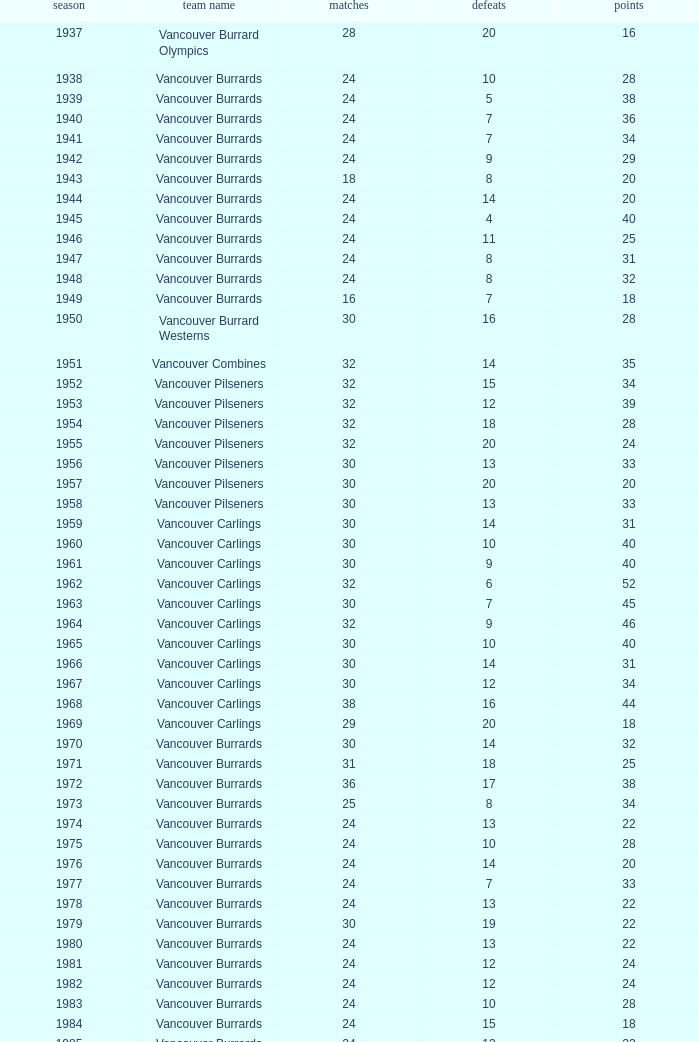What's the total number of games with more than 20 points for the 1976 season? 0.0. Can you parse all the data within this table? {'header': ['season', 'team name', 'matches', 'defeats', 'points'], 'rows': [['1937', 'Vancouver Burrard Olympics', '28', '20', '16'], ['1938', 'Vancouver Burrards', '24', '10', '28'], ['1939', 'Vancouver Burrards', '24', '5', '38'], ['1940', 'Vancouver Burrards', '24', '7', '36'], ['1941', 'Vancouver Burrards', '24', '7', '34'], ['1942', 'Vancouver Burrards', '24', '9', '29'], ['1943', 'Vancouver Burrards', '18', '8', '20'], ['1944', 'Vancouver Burrards', '24', '14', '20'], ['1945', 'Vancouver Burrards', '24', '4', '40'], ['1946', 'Vancouver Burrards', '24', '11', '25'], ['1947', 'Vancouver Burrards', '24', '8', '31'], ['1948', 'Vancouver Burrards', '24', '8', '32'], ['1949', 'Vancouver Burrards', '16', '7', '18'], ['1950', 'Vancouver Burrard Westerns', '30', '16', '28'], ['1951', 'Vancouver Combines', '32', '14', '35'], ['1952', 'Vancouver Pilseners', '32', '15', '34'], ['1953', 'Vancouver Pilseners', '32', '12', '39'], ['1954', 'Vancouver Pilseners', '32', '18', '28'], ['1955', 'Vancouver Pilseners', '32', '20', '24'], ['1956', 'Vancouver Pilseners', '30', '13', '33'], ['1957', 'Vancouver Pilseners', '30', '20', '20'], ['1958', 'Vancouver Pilseners', '30', '13', '33'], ['1959', 'Vancouver Carlings', '30', '14', '31'], ['1960', 'Vancouver Carlings', '30', '10', '40'], ['1961', 'Vancouver Carlings', '30', '9', '40'], ['1962', 'Vancouver Carlings', '32', '6', '52'], ['1963', 'Vancouver Carlings', '30', '7', '45'], ['1964', 'Vancouver Carlings', '32', '9', '46'], ['1965', 'Vancouver Carlings', '30', '10', '40'], ['1966', 'Vancouver Carlings', '30', '14', '31'], ['1967', 'Vancouver Carlings', '30', '12', '34'], ['1968', 'Vancouver Carlings', '38', '16', '44'], ['1969', 'Vancouver Carlings', '29', '20', '18'], ['1970', 'Vancouver Burrards', '30', '14', '32'], ['1971', 'Vancouver Burrards', '31', '18', '25'], ['1972', 'Vancouver Burrards', '36', '17', '38'], ['1973', 'Vancouver Burrards', '25', '8', '34'], ['1974', 'Vancouver Burrards', '24', '13', '22'], ['1975', 'Vancouver Burrards', '24', '10', '28'], ['1976', 'Vancouver Burrards', '24', '14', '20'], ['1977', 'Vancouver Burrards', '24', '7', '33'], ['1978', 'Vancouver Burrards', '24', '13', '22'], ['1979', 'Vancouver Burrards', '30', '19', '22'], ['1980', 'Vancouver Burrards', '24', '13', '22'], ['1981', 'Vancouver Burrards', '24', '12', '24'], ['1982', 'Vancouver Burrards', '24', '12', '24'], ['1983', 'Vancouver Burrards', '24', '10', '28'], ['1984', 'Vancouver Burrards', '24', '15', '18'], ['1985', 'Vancouver Burrards', '24', '13', '22'], ['1986', 'Vancouver Burrards', '24', '11', '26'], ['1987', 'Vancouver Burrards', '24', '14', '20'], ['1988', 'Vancouver Burrards', '24', '13', '22'], ['1989', 'Vancouver Burrards', '24', '15', '18'], ['1990', 'Vancouver Burrards', '24', '8', '32'], ['1991', 'Vancouver Burrards', '24', '16', '16'], ['1992', 'Vancouver Burrards', '24', '15', '18'], ['1993', 'Vancouver Burrards', '24', '20', '8'], ['1994', 'Surrey Burrards', '20', '12', '16'], ['1995', 'Surrey Burrards', '25', '19', '11'], ['1996', 'Maple Ridge Burrards', '20', '8', '23'], ['1997', 'Maple Ridge Burrards', '20', '8', '23'], ['1998', 'Maple Ridge Burrards', '25', '8', '32'], ['1999', 'Maple Ridge Burrards', '25', '15', '20'], ['2000', 'Maple Ridge Burrards', '25', '16', '18'], ['2001', 'Maple Ridge Burrards', '20', '16', '8'], ['2002', 'Maple Ridge Burrards', '20', '15', '8'], ['2003', 'Maple Ridge Burrards', '20', '15', '10'], ['2004', 'Maple Ridge Burrards', '20', '12', '16'], ['2005', 'Maple Ridge Burrards', '18', '8', '19'], ['2006', 'Maple Ridge Burrards', '18', '11', '14'], ['2007', 'Maple Ridge Burrards', '18', '11', '14'], ['2008', 'Maple Ridge Burrards', '18', '13', '10'], ['2009', 'Maple Ridge Burrards', '18', '11', '14'], ['2010', 'Maple Ridge Burrards', '18', '9', '18'], ['Total', '74 seasons', '1,879', '913', '1,916']]} 